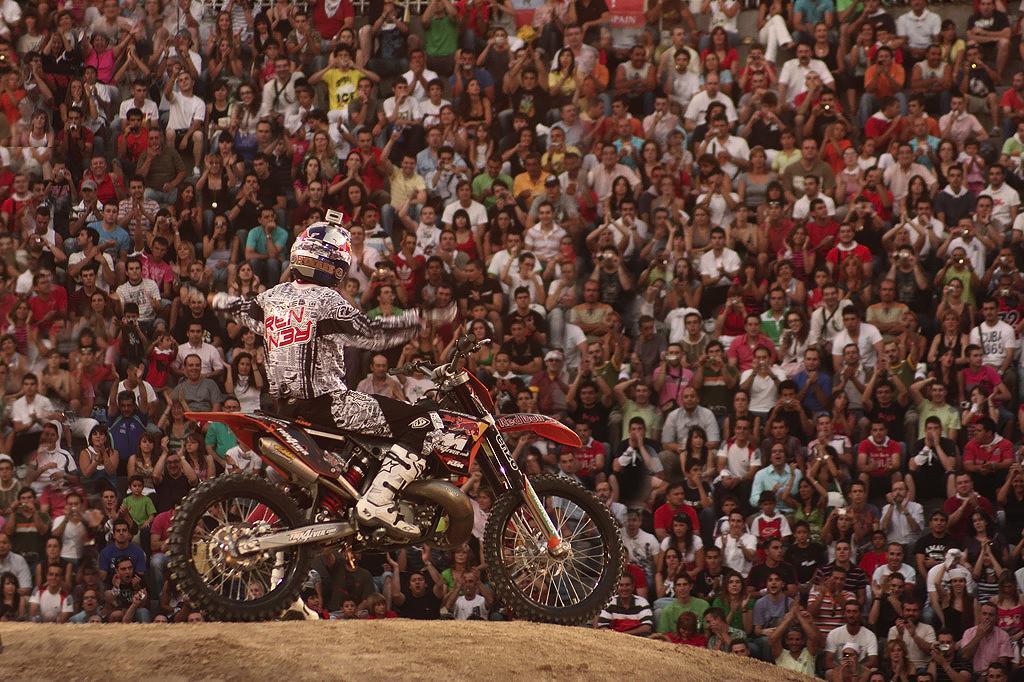Could you give a brief overview of what you see in this image? In the image there is a racer sitting on a bike and around him there is a huge crowd,they are cheering the man. 